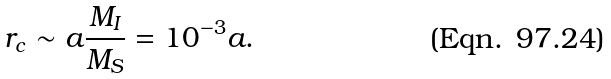Convert formula to latex. <formula><loc_0><loc_0><loc_500><loc_500>r _ { c } \sim a \frac { M _ { I } } { M _ { S } } = 1 0 ^ { - 3 } a .</formula> 